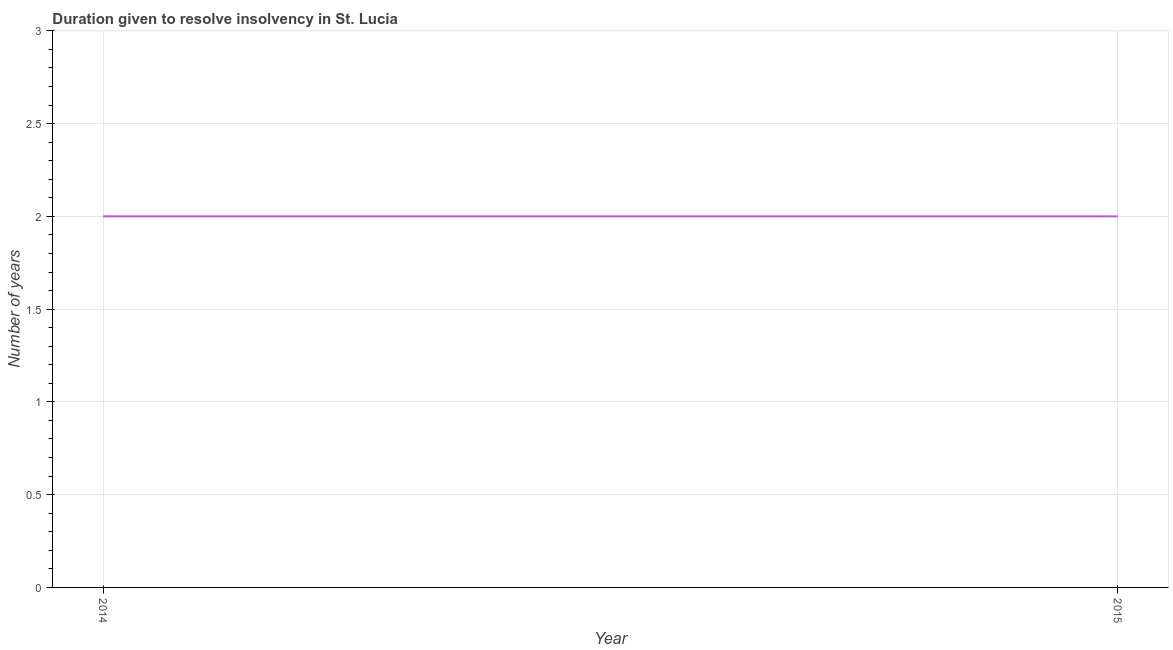What is the number of years to resolve insolvency in 2015?
Your response must be concise. 2. Across all years, what is the maximum number of years to resolve insolvency?
Offer a very short reply. 2. Across all years, what is the minimum number of years to resolve insolvency?
Provide a short and direct response. 2. In which year was the number of years to resolve insolvency minimum?
Keep it short and to the point. 2014. What is the sum of the number of years to resolve insolvency?
Provide a short and direct response. 4. What is the average number of years to resolve insolvency per year?
Make the answer very short. 2. In how many years, is the number of years to resolve insolvency greater than 0.2 ?
Offer a very short reply. 2. What is the ratio of the number of years to resolve insolvency in 2014 to that in 2015?
Provide a short and direct response. 1. In how many years, is the number of years to resolve insolvency greater than the average number of years to resolve insolvency taken over all years?
Keep it short and to the point. 0. Does the number of years to resolve insolvency monotonically increase over the years?
Ensure brevity in your answer.  No. What is the difference between two consecutive major ticks on the Y-axis?
Provide a short and direct response. 0.5. What is the title of the graph?
Provide a short and direct response. Duration given to resolve insolvency in St. Lucia. What is the label or title of the Y-axis?
Offer a very short reply. Number of years. What is the Number of years of 2014?
Provide a short and direct response. 2. What is the Number of years of 2015?
Your answer should be very brief. 2. 